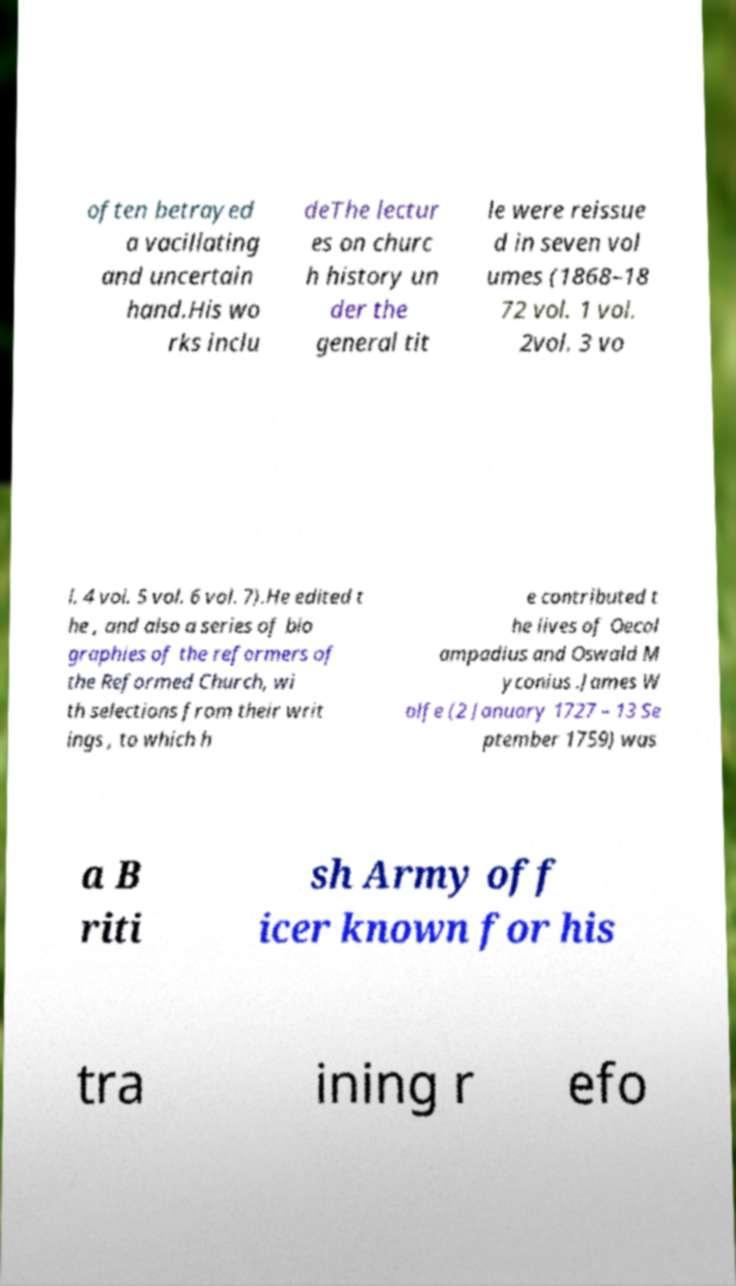Can you read and provide the text displayed in the image?This photo seems to have some interesting text. Can you extract and type it out for me? often betrayed a vacillating and uncertain hand.His wo rks inclu deThe lectur es on churc h history un der the general tit le were reissue d in seven vol umes (1868–18 72 vol. 1 vol. 2vol. 3 vo l. 4 vol. 5 vol. 6 vol. 7).He edited t he , and also a series of bio graphies of the reformers of the Reformed Church, wi th selections from their writ ings , to which h e contributed t he lives of Oecol ampadius and Oswald M yconius .James W olfe (2 January 1727 – 13 Se ptember 1759) was a B riti sh Army off icer known for his tra ining r efo 